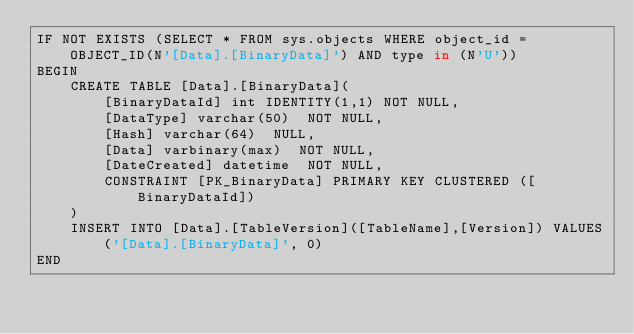Convert code to text. <code><loc_0><loc_0><loc_500><loc_500><_SQL_>IF NOT EXISTS (SELECT * FROM sys.objects WHERE object_id = OBJECT_ID(N'[Data].[BinaryData]') AND type in (N'U'))
BEGIN
	CREATE TABLE [Data].[BinaryData](
		[BinaryDataId] int IDENTITY(1,1) NOT NULL,
		[DataType] varchar(50)  NOT NULL,
		[Hash] varchar(64)  NULL,
		[Data] varbinary(max)  NOT NULL,
		[DateCreated] datetime  NOT NULL,
		CONSTRAINT [PK_BinaryData] PRIMARY KEY CLUSTERED ([BinaryDataId])
	)  
	INSERT INTO [Data].[TableVersion]([TableName],[Version]) VALUES('[Data].[BinaryData]', 0)
END
</code> 